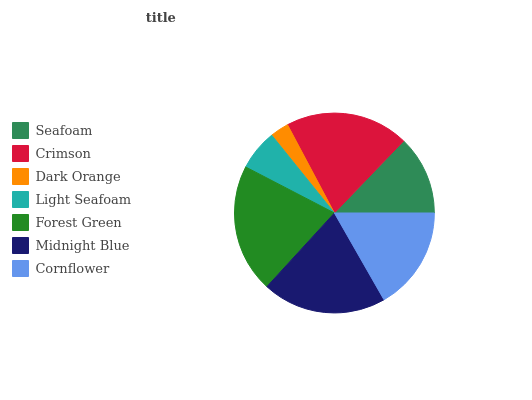Is Dark Orange the minimum?
Answer yes or no. Yes. Is Forest Green the maximum?
Answer yes or no. Yes. Is Crimson the minimum?
Answer yes or no. No. Is Crimson the maximum?
Answer yes or no. No. Is Crimson greater than Seafoam?
Answer yes or no. Yes. Is Seafoam less than Crimson?
Answer yes or no. Yes. Is Seafoam greater than Crimson?
Answer yes or no. No. Is Crimson less than Seafoam?
Answer yes or no. No. Is Cornflower the high median?
Answer yes or no. Yes. Is Cornflower the low median?
Answer yes or no. Yes. Is Midnight Blue the high median?
Answer yes or no. No. Is Forest Green the low median?
Answer yes or no. No. 